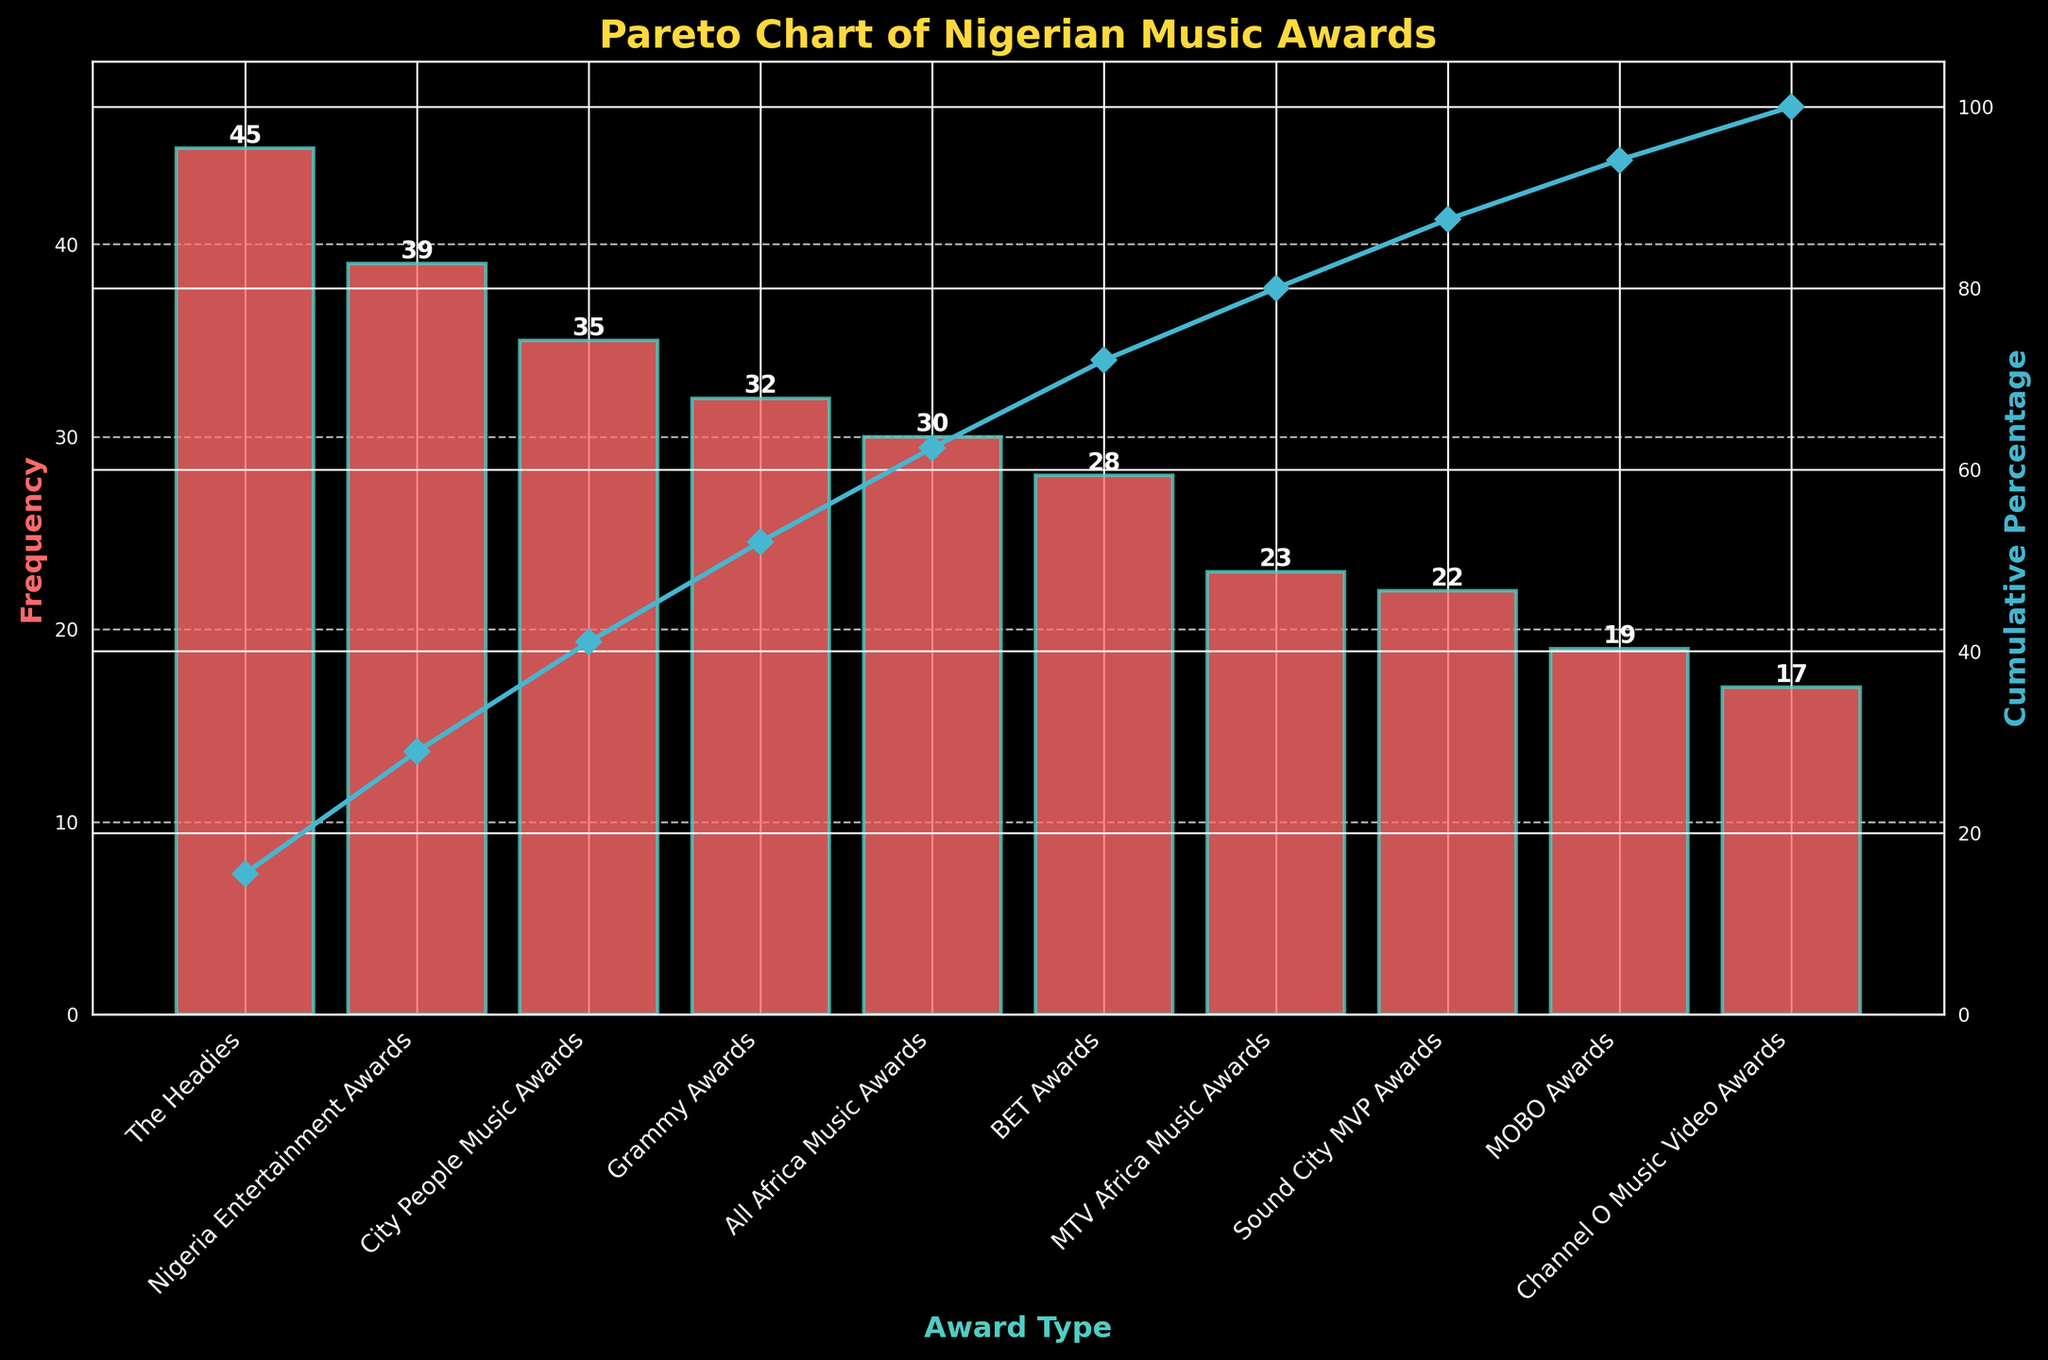Which award type has the highest frequency in the chart? The chart has a bar labeled 'The Headies' which extends further up than any other bar, showing it has the highest frequency.
Answer: The Headies What is the frequency of the Nigeria Entertainment Awards? Identify the bar labeled 'Nigeria Entertainment Awards' and read its height. It reaches up to the value of 39 on the y-axis.
Answer: 39 How many award types have a cumulative percentage over 50%? Check the cumulative percentage line. The cumulative percentage exceeds 50% just after 'The Headies' and 'Nigeria Entertainment Awards,' meaning it includes these first two categories.
Answer: 2 What is the difference in frequency between the BET Awards and the MOBO Awards? Identify the bars for 'BET Awards' (28) and 'MOBO Awards' (19). Subtract the MOBO Awards' frequency from the BET Awards' frequency: 28 - 19 = 9.
Answer: 9 Which award type has the smallest frequency, and how many awards are given in that category? The chart shows the shortest bar is 'Channel O Music Video Awards,' and its height is at 17.
Answer: Channel O Music Video Awards, 17 What is the cumulative percentage after including the top three award types based on frequency? The top three awards by frequency are 'The Headies' (45), 'Nigeria Entertainment Awards' (39), and 'City People Music Awards' (35). First, sum their frequencies: 45 + 39 + 35 = 119. Then, use the total frequency, 290, to calculate: (119/290) * 100 ≈ 41.03%.
Answer: 41.03% Which has a higher frequency, the Grammy Awards or the MTV Africa Music Awards? Compare the heights of 'Grammy Awards' (32) and 'MTV Africa Music Awards' (23) bars.
Answer: Grammy Awards If the cumulative percentage at the Grammy Awards is approximately 86%, what is the likely reason for this value falling at that point? The cumulative percentage line shows that most awards have less frequency compared to the top few. Therefore, by the time the cumulative percentage includes the Grammy Awards (32), which is relatively high, it has already covered a significant portion of total frequencies.
Answer: Few award types dominate What two properties are displayed on the Y-axes of the Pareto chart? Identify the labels and values shown along the Y-axes. The left Y-axis indicates 'Frequency,' and the right Y-axis shows 'Cumulative Percentage.'
Answer: Frequency, Cumulative Percentage How does the frequency of the City People Music Awards compare with the Sound City MVP Awards? Observe the heights of the bars labeled 'City People Music Awards' (35) and 'Sound City MVP Awards' (22). City People Music Awards' bar is higher.
Answer: City People Music Awards are higher 